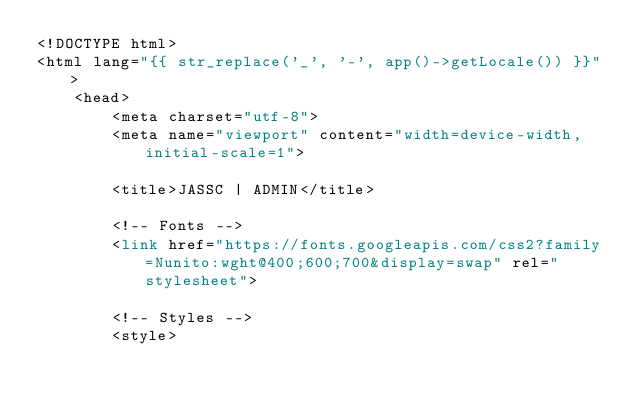Convert code to text. <code><loc_0><loc_0><loc_500><loc_500><_PHP_><!DOCTYPE html>
<html lang="{{ str_replace('_', '-', app()->getLocale()) }}">
    <head>
        <meta charset="utf-8">
        <meta name="viewport" content="width=device-width, initial-scale=1">

        <title>JASSC | ADMIN</title>

        <!-- Fonts -->
        <link href="https://fonts.googleapis.com/css2?family=Nunito:wght@400;600;700&display=swap" rel="stylesheet">

        <!-- Styles -->
        <style></code> 